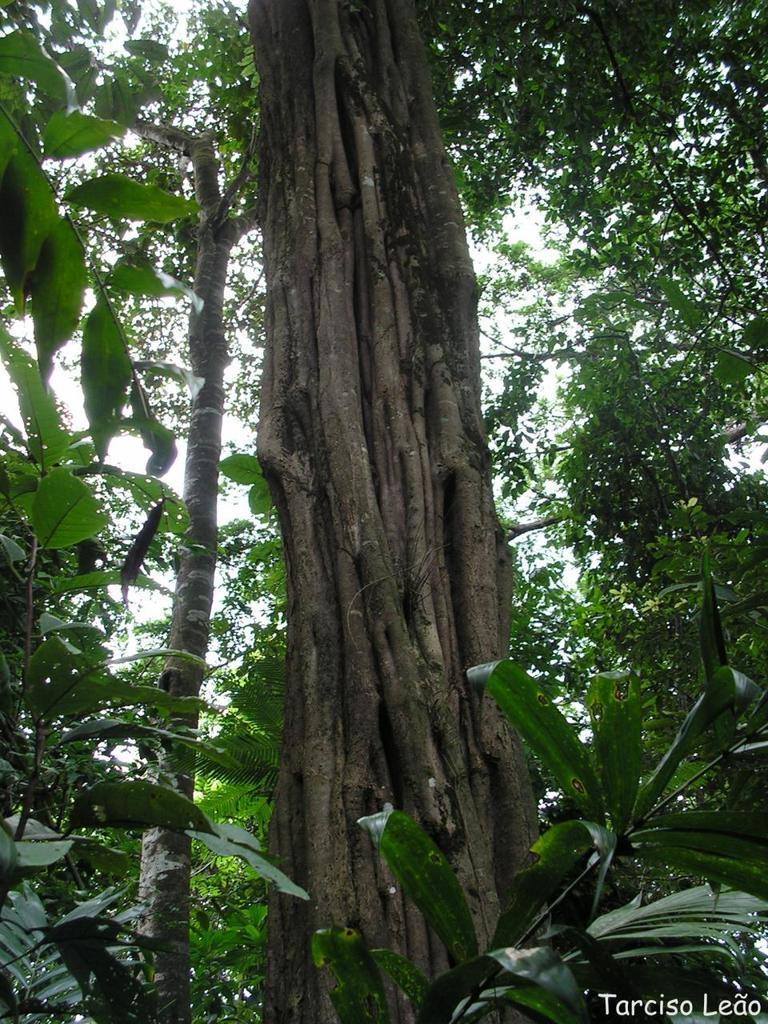What is the main subject of the image? The main subject of the image is a tree trunk. Are there any other trees visible in the image? Yes, there are trees near the tree trunk. Is there any additional information or markings in the image? There is a watermark in the right bottom corner of the image. What type of grip can be seen on the tree trunk in the image? There is no grip visible on the tree trunk in the image. What type of grain is present in the tree trunk in the image? The image does not provide information about the grain of the tree trunk. 